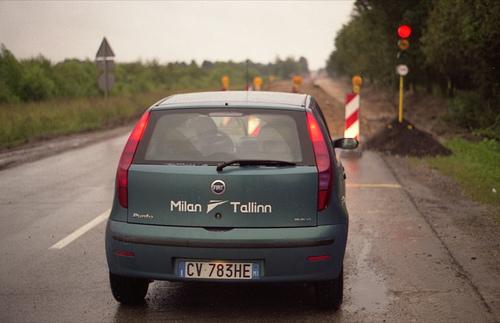What color is the license plate?
Short answer required. White. What does the car say?
Answer briefly. Milan tallinn. What is on the license plate?
Concise answer only. Cv 783he. What make of car is this?
Be succinct. Fiat. What is in front of the car?
Give a very brief answer. Construction. What is written on the car?
Be succinct. Milan tallinn. What is on the car?
Quick response, please. Milan tallinn. What is the license plate number?
Answer briefly. Cv 783he. Who is on the window?
Quick response, please. No one. What is coming up on the left?
Quick response, please. Sign. What city is this?
Concise answer only. Milan. Are the vehicles stopped for a traffic light?
Write a very short answer. Yes. 